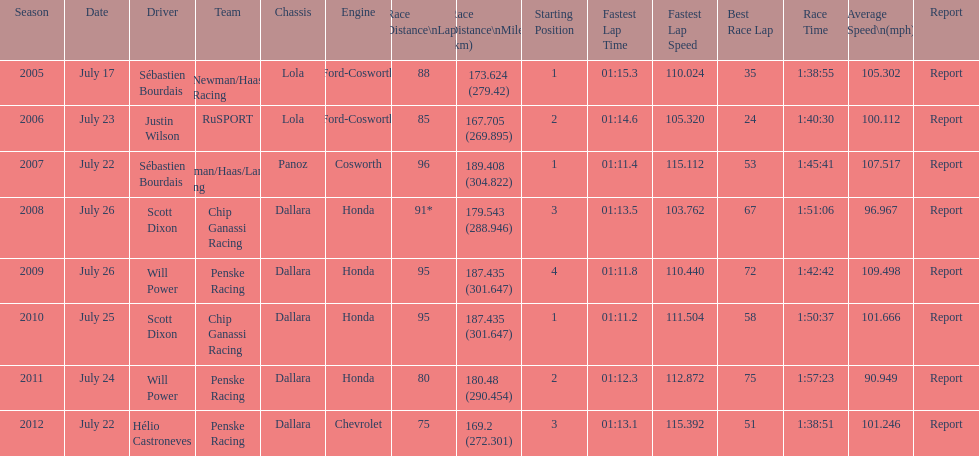How many total honda engines were there? 4. 